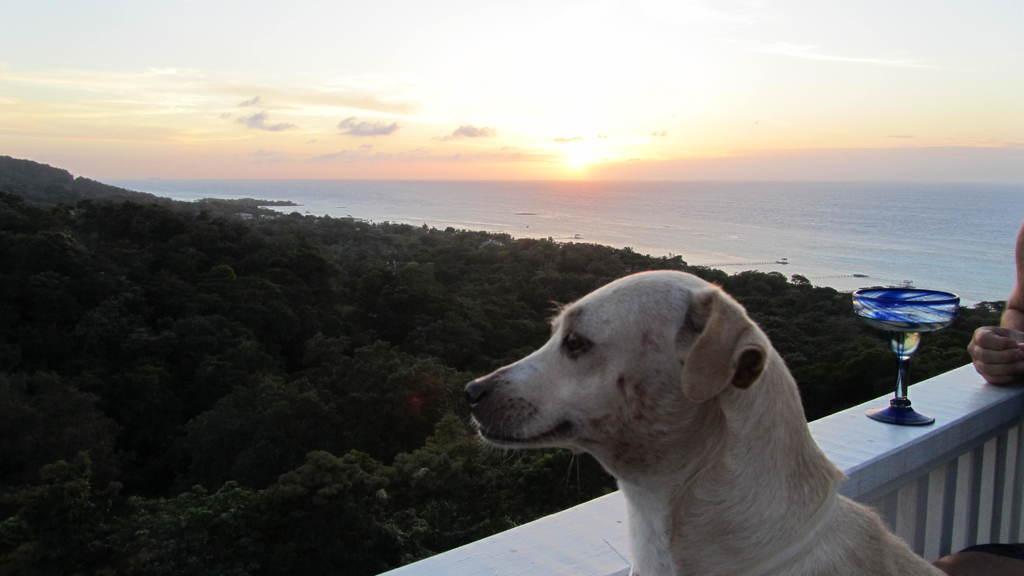Please provide a concise description of this image. In this image we can see human hands and the glass placed on the railing and we can also see dog, trees and sky. 